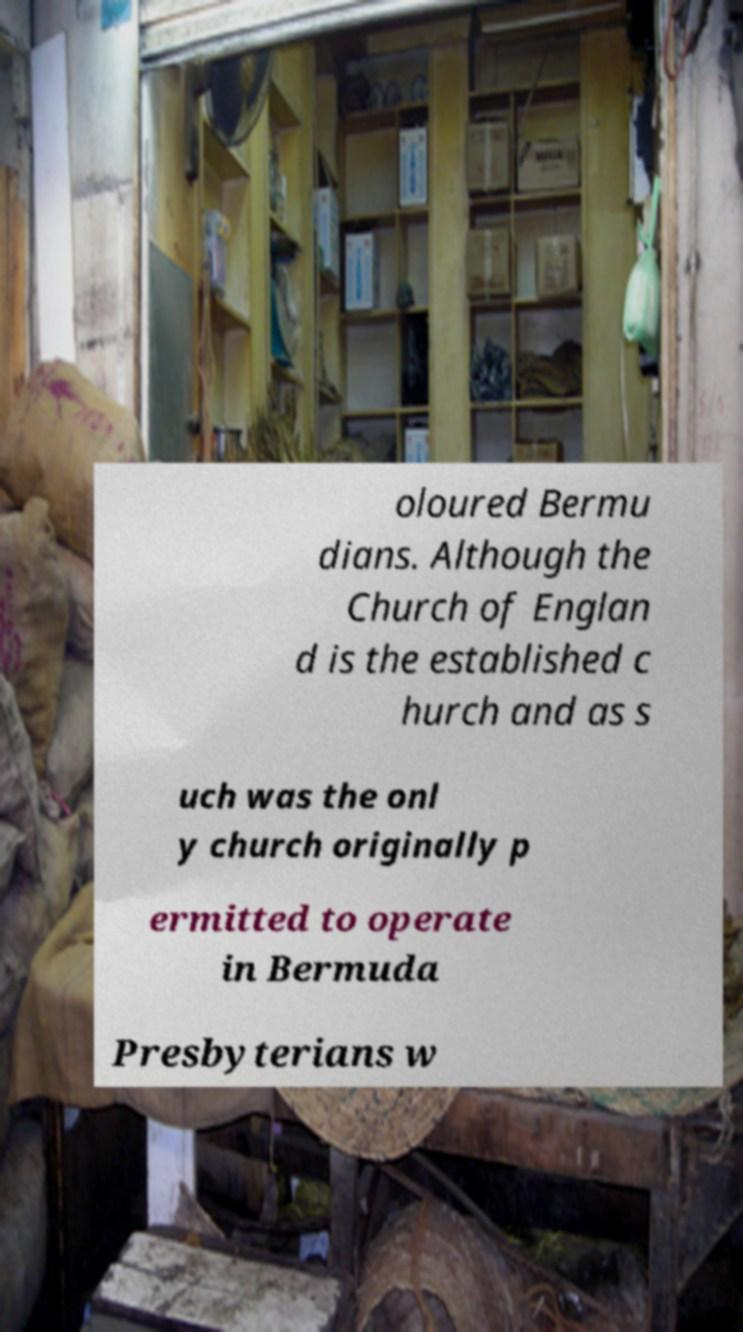Could you assist in decoding the text presented in this image and type it out clearly? oloured Bermu dians. Although the Church of Englan d is the established c hurch and as s uch was the onl y church originally p ermitted to operate in Bermuda Presbyterians w 